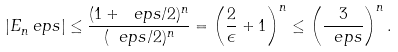<formula> <loc_0><loc_0><loc_500><loc_500>| E _ { n } ^ { \ } e p s | \leq \frac { ( 1 + \ e p s / 2 ) ^ { n } } { ( \ e p s / 2 ) ^ { n } } = \left ( \frac { 2 } { \epsilon } + 1 \right ) ^ { n } \leq \left ( \frac { 3 } { \ e p s } \right ) ^ { n } .</formula> 